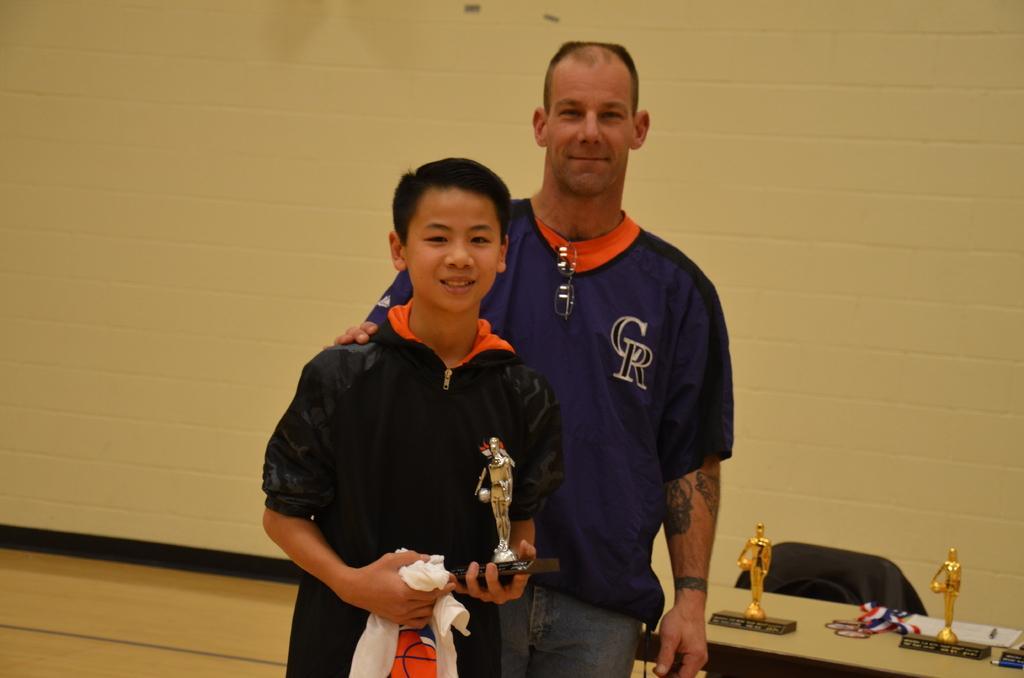Could you give a brief overview of what you see in this image? In this image I can see two persons standing, the person at right is wearing blue color shirt and the person at left is wearing black color shirt and holding some object. In the background I can see few objects on the table and the wall is in cream color. 